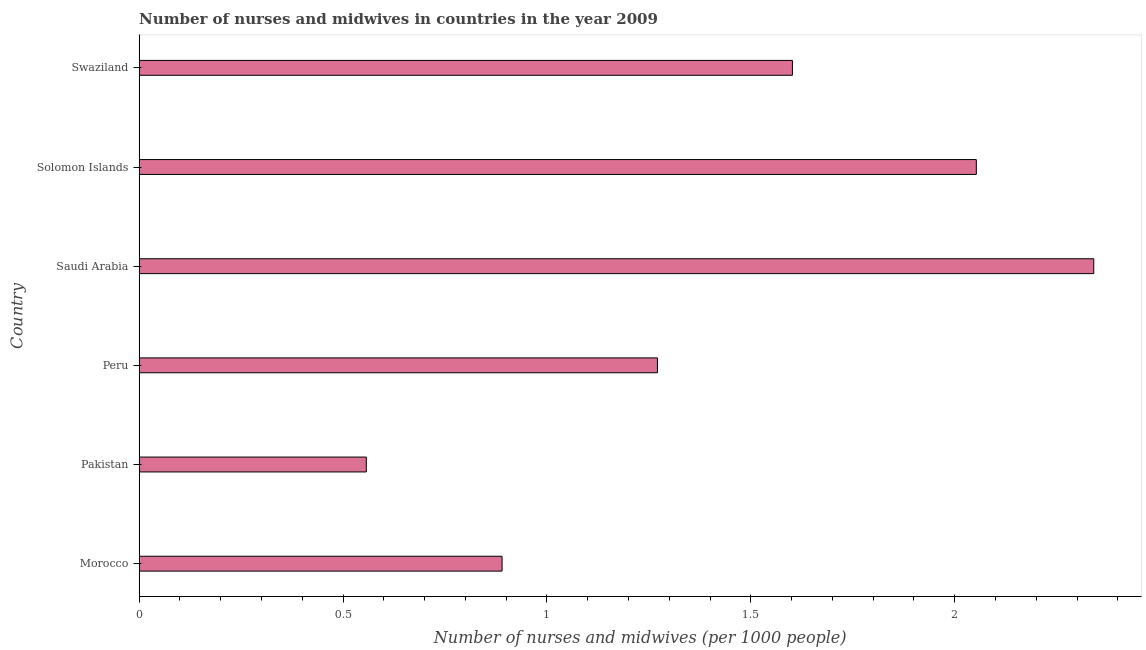Does the graph contain any zero values?
Your answer should be compact. No. What is the title of the graph?
Your answer should be compact. Number of nurses and midwives in countries in the year 2009. What is the label or title of the X-axis?
Your answer should be compact. Number of nurses and midwives (per 1000 people). What is the label or title of the Y-axis?
Offer a very short reply. Country. What is the number of nurses and midwives in Saudi Arabia?
Provide a succinct answer. 2.34. Across all countries, what is the maximum number of nurses and midwives?
Provide a short and direct response. 2.34. Across all countries, what is the minimum number of nurses and midwives?
Your response must be concise. 0.56. In which country was the number of nurses and midwives maximum?
Your answer should be compact. Saudi Arabia. What is the sum of the number of nurses and midwives?
Ensure brevity in your answer.  8.71. What is the difference between the number of nurses and midwives in Morocco and Saudi Arabia?
Your answer should be compact. -1.45. What is the average number of nurses and midwives per country?
Offer a very short reply. 1.45. What is the median number of nurses and midwives?
Your answer should be compact. 1.44. In how many countries, is the number of nurses and midwives greater than 0.8 ?
Provide a short and direct response. 5. What is the ratio of the number of nurses and midwives in Peru to that in Solomon Islands?
Make the answer very short. 0.62. Is the number of nurses and midwives in Solomon Islands less than that in Swaziland?
Provide a short and direct response. No. Is the difference between the number of nurses and midwives in Saudi Arabia and Solomon Islands greater than the difference between any two countries?
Provide a succinct answer. No. What is the difference between the highest and the second highest number of nurses and midwives?
Your answer should be compact. 0.29. What is the difference between the highest and the lowest number of nurses and midwives?
Give a very brief answer. 1.78. In how many countries, is the number of nurses and midwives greater than the average number of nurses and midwives taken over all countries?
Keep it short and to the point. 3. Are all the bars in the graph horizontal?
Offer a very short reply. Yes. How many countries are there in the graph?
Keep it short and to the point. 6. What is the difference between two consecutive major ticks on the X-axis?
Give a very brief answer. 0.5. What is the Number of nurses and midwives (per 1000 people) in Morocco?
Provide a succinct answer. 0.89. What is the Number of nurses and midwives (per 1000 people) in Pakistan?
Ensure brevity in your answer.  0.56. What is the Number of nurses and midwives (per 1000 people) in Peru?
Provide a succinct answer. 1.27. What is the Number of nurses and midwives (per 1000 people) in Saudi Arabia?
Make the answer very short. 2.34. What is the Number of nurses and midwives (per 1000 people) of Solomon Islands?
Your response must be concise. 2.05. What is the Number of nurses and midwives (per 1000 people) of Swaziland?
Offer a very short reply. 1.6. What is the difference between the Number of nurses and midwives (per 1000 people) in Morocco and Pakistan?
Your answer should be very brief. 0.33. What is the difference between the Number of nurses and midwives (per 1000 people) in Morocco and Peru?
Provide a short and direct response. -0.38. What is the difference between the Number of nurses and midwives (per 1000 people) in Morocco and Saudi Arabia?
Offer a very short reply. -1.45. What is the difference between the Number of nurses and midwives (per 1000 people) in Morocco and Solomon Islands?
Your answer should be compact. -1.16. What is the difference between the Number of nurses and midwives (per 1000 people) in Morocco and Swaziland?
Provide a short and direct response. -0.71. What is the difference between the Number of nurses and midwives (per 1000 people) in Pakistan and Peru?
Offer a very short reply. -0.71. What is the difference between the Number of nurses and midwives (per 1000 people) in Pakistan and Saudi Arabia?
Provide a short and direct response. -1.78. What is the difference between the Number of nurses and midwives (per 1000 people) in Pakistan and Solomon Islands?
Your answer should be compact. -1.5. What is the difference between the Number of nurses and midwives (per 1000 people) in Pakistan and Swaziland?
Ensure brevity in your answer.  -1.04. What is the difference between the Number of nurses and midwives (per 1000 people) in Peru and Saudi Arabia?
Make the answer very short. -1.07. What is the difference between the Number of nurses and midwives (per 1000 people) in Peru and Solomon Islands?
Give a very brief answer. -0.78. What is the difference between the Number of nurses and midwives (per 1000 people) in Peru and Swaziland?
Ensure brevity in your answer.  -0.33. What is the difference between the Number of nurses and midwives (per 1000 people) in Saudi Arabia and Solomon Islands?
Offer a very short reply. 0.29. What is the difference between the Number of nurses and midwives (per 1000 people) in Saudi Arabia and Swaziland?
Offer a very short reply. 0.74. What is the difference between the Number of nurses and midwives (per 1000 people) in Solomon Islands and Swaziland?
Keep it short and to the point. 0.45. What is the ratio of the Number of nurses and midwives (per 1000 people) in Morocco to that in Pakistan?
Keep it short and to the point. 1.6. What is the ratio of the Number of nurses and midwives (per 1000 people) in Morocco to that in Peru?
Give a very brief answer. 0.7. What is the ratio of the Number of nurses and midwives (per 1000 people) in Morocco to that in Saudi Arabia?
Make the answer very short. 0.38. What is the ratio of the Number of nurses and midwives (per 1000 people) in Morocco to that in Solomon Islands?
Provide a succinct answer. 0.43. What is the ratio of the Number of nurses and midwives (per 1000 people) in Morocco to that in Swaziland?
Your answer should be compact. 0.56. What is the ratio of the Number of nurses and midwives (per 1000 people) in Pakistan to that in Peru?
Offer a terse response. 0.44. What is the ratio of the Number of nurses and midwives (per 1000 people) in Pakistan to that in Saudi Arabia?
Ensure brevity in your answer.  0.24. What is the ratio of the Number of nurses and midwives (per 1000 people) in Pakistan to that in Solomon Islands?
Offer a very short reply. 0.27. What is the ratio of the Number of nurses and midwives (per 1000 people) in Pakistan to that in Swaziland?
Provide a succinct answer. 0.35. What is the ratio of the Number of nurses and midwives (per 1000 people) in Peru to that in Saudi Arabia?
Your response must be concise. 0.54. What is the ratio of the Number of nurses and midwives (per 1000 people) in Peru to that in Solomon Islands?
Provide a short and direct response. 0.62. What is the ratio of the Number of nurses and midwives (per 1000 people) in Peru to that in Swaziland?
Your answer should be very brief. 0.79. What is the ratio of the Number of nurses and midwives (per 1000 people) in Saudi Arabia to that in Solomon Islands?
Make the answer very short. 1.14. What is the ratio of the Number of nurses and midwives (per 1000 people) in Saudi Arabia to that in Swaziland?
Offer a very short reply. 1.46. What is the ratio of the Number of nurses and midwives (per 1000 people) in Solomon Islands to that in Swaziland?
Provide a short and direct response. 1.28. 